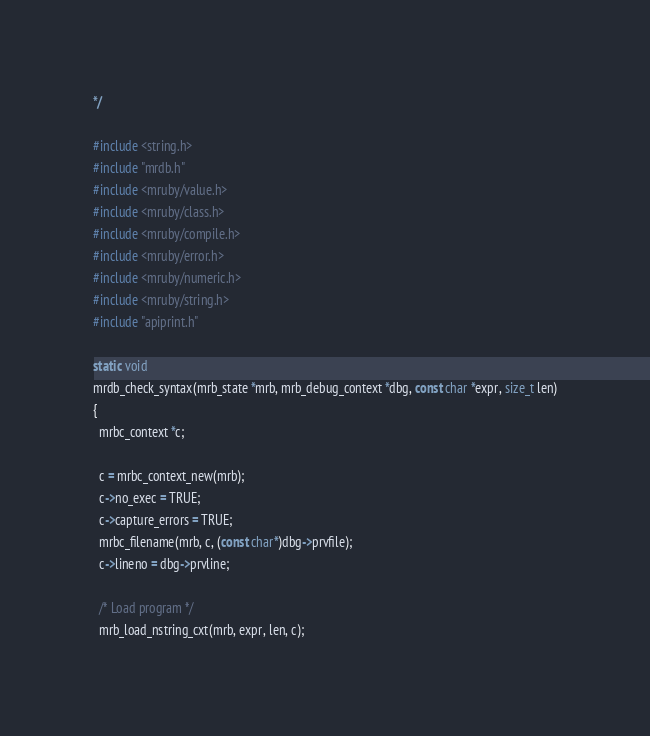Convert code to text. <code><loc_0><loc_0><loc_500><loc_500><_C_>*/

#include <string.h>
#include "mrdb.h"
#include <mruby/value.h>
#include <mruby/class.h>
#include <mruby/compile.h>
#include <mruby/error.h>
#include <mruby/numeric.h>
#include <mruby/string.h>
#include "apiprint.h"

static void
mrdb_check_syntax(mrb_state *mrb, mrb_debug_context *dbg, const char *expr, size_t len)
{
  mrbc_context *c;

  c = mrbc_context_new(mrb);
  c->no_exec = TRUE;
  c->capture_errors = TRUE;
  mrbc_filename(mrb, c, (const char*)dbg->prvfile);
  c->lineno = dbg->prvline;

  /* Load program */
  mrb_load_nstring_cxt(mrb, expr, len, c);
</code> 